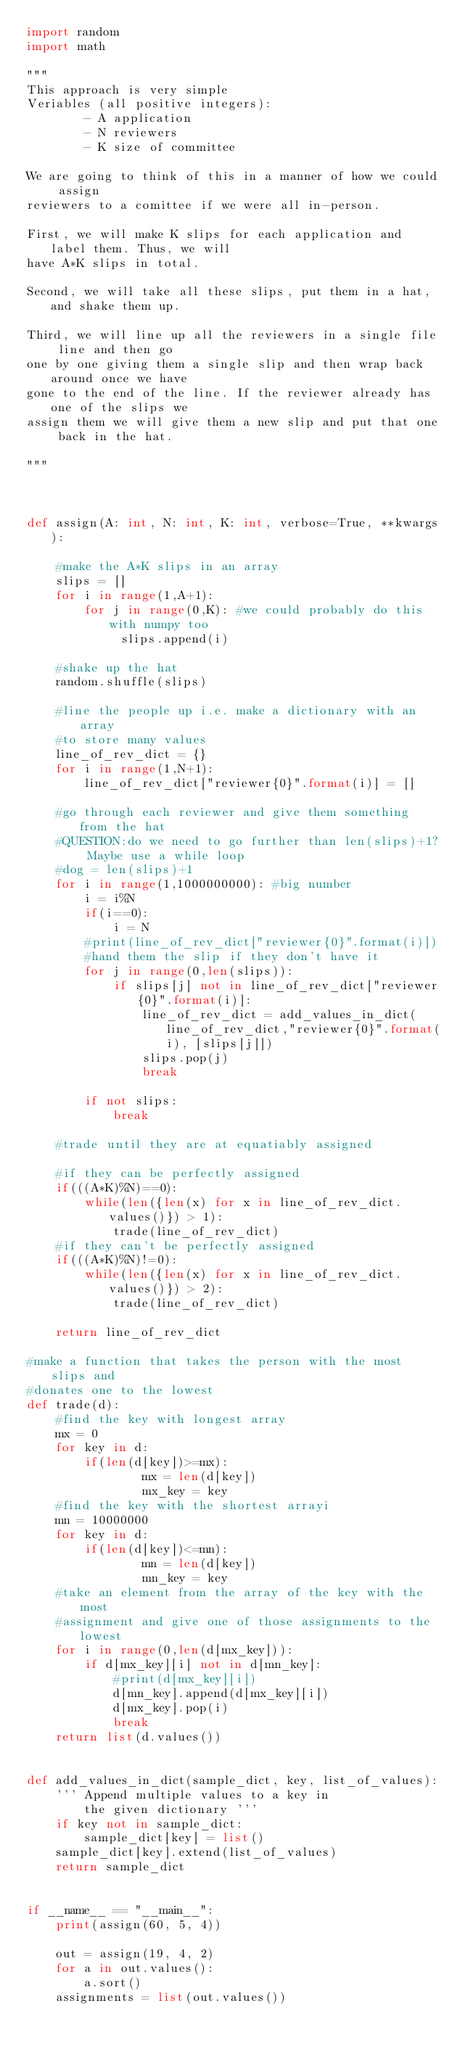<code> <loc_0><loc_0><loc_500><loc_500><_Python_>import random
import math 

"""
This approach is very simple
Veriables (all positive integers):
        - A application
        - N reviewers
        - K size of committee

We are going to think of this in a manner of how we could assign 
reviewers to a comittee if we were all in-person.

First, we will make K slips for each application and label them. Thus, we will
have A*K slips in total.

Second, we will take all these slips, put them in a hat, and shake them up.

Third, we will line up all the reviewers in a single file line and then go
one by one giving them a single slip and then wrap back around once we have
gone to the end of the line. If the reviewer already has one of the slips we
assign them we will give them a new slip and put that one back in the hat.

"""



def assign(A: int, N: int, K: int, verbose=True, **kwargs):
    
    #make the A*K slips in an array
    slips = []
    for i in range(1,A+1):
        for j in range(0,K): #we could probably do this with numpy too
             slips.append(i)

    #shake up the hat
    random.shuffle(slips)

    #line the people up i.e. make a dictionary with an array
    #to store many values 
    line_of_rev_dict = {}
    for i in range(1,N+1):
        line_of_rev_dict["reviewer{0}".format(i)] = []

    #go through each reviewer and give them something from the hat
    #QUESTION:do we need to go further than len(slips)+1? Maybe use a while loop
    #dog = len(slips)+1
    for i in range(1,1000000000): #big number
        i = i%N
        if(i==0):
            i = N
        #print(line_of_rev_dict["reviewer{0}".format(i)])
        #hand them the slip if they don't have it 
        for j in range(0,len(slips)):
            if slips[j] not in line_of_rev_dict["reviewer{0}".format(i)]:
                line_of_rev_dict = add_values_in_dict(line_of_rev_dict,"reviewer{0}".format(i), [slips[j]])
                slips.pop(j)
                break

        if not slips:
            break

    #trade until they are at equatiably assigned 

    #if they can be perfectly assigned 
    if(((A*K)%N)==0):
        while(len({len(x) for x in line_of_rev_dict.values()}) > 1):
            trade(line_of_rev_dict)
    #if they can't be perfectly assigned 
    if(((A*K)%N)!=0):
        while(len({len(x) for x in line_of_rev_dict.values()}) > 2):
            trade(line_of_rev_dict)

    return line_of_rev_dict

#make a function that takes the person with the most slips and 
#donates one to the lowest 
def trade(d):
    #find the key with longest array 
    mx = 0
    for key in d:
        if(len(d[key])>=mx):
                mx = len(d[key])
                mx_key = key
    #find the key with the shortest arrayi
    mn = 10000000
    for key in d:
        if(len(d[key])<=mn):
                mn = len(d[key])
                mn_key = key
    #take an element from the array of the key with the most 
    #assignment and give one of those assignments to the lowest 
    for i in range(0,len(d[mx_key])):
        if d[mx_key][i] not in d[mn_key]:
            #print(d[mx_key][i])
            d[mn_key].append(d[mx_key][i])
            d[mx_key].pop(i)
            break     
    return list(d.values())


def add_values_in_dict(sample_dict, key, list_of_values):
    ''' Append multiple values to a key in 
        the given dictionary '''
    if key not in sample_dict:
        sample_dict[key] = list()
    sample_dict[key].extend(list_of_values)
    return sample_dict


if __name__ == "__main__":
    print(assign(60, 5, 4))

    out = assign(19, 4, 2)
    for a in out.values():
        a.sort()
    assignments = list(out.values())

</code> 